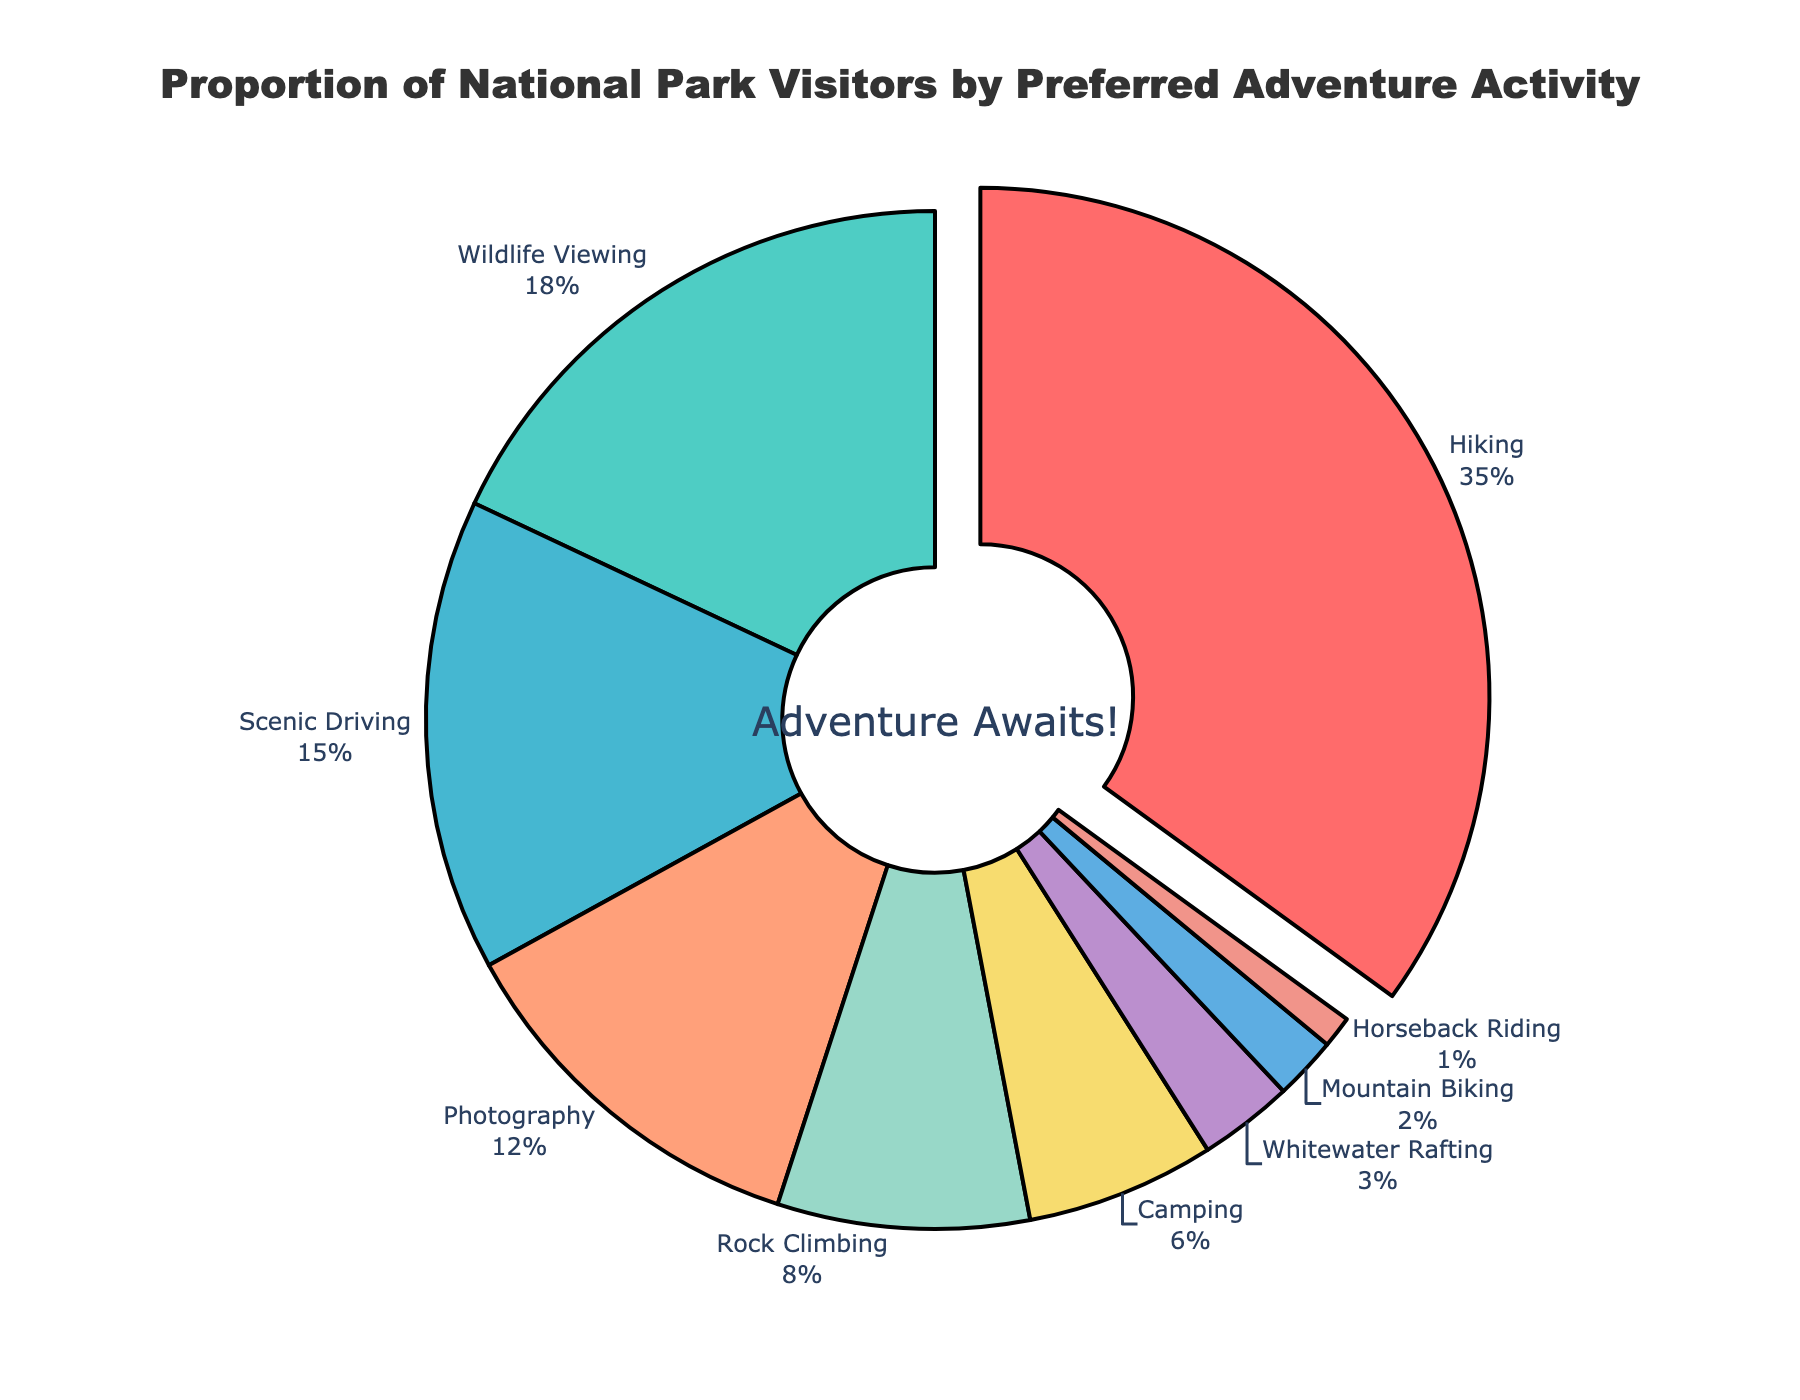Which adventure activity has the highest proportion of visitors? The pie chart highlights that "Hiking" has the largest segment, and it is also the only activity pulled out to emphasize its highest percentage.
Answer: Hiking What is the combined percentage of visitors who prefer Wildlife Viewing and Scenic Driving? From the chart, Wildlife Viewing has 18% and Scenic Driving has 15%. Summing these percentages: 18% + 15% = 33%.
Answer: 33% How much more popular is Hiking compared to Photography among national park visitors? Hiking is at 35% while Photography is at 12%. The difference is 35% - 12% = 23%.
Answer: 23% Which activity has a smaller proportion: Mountain Biking or Horseback Riding? Checking the pie chart, Mountain Biking is at 2%, and Horseback Riding is at 1%. Hence, Horseback Riding has a smaller proportion.
Answer: Horseback Riding What is the visual attribute used to emphasize the most popular activity? In the pie chart, the segment for Hiking is slightly pulled out from the circle to highlight it as the most popular activity.
Answer: Segment is pulled out What is the total percentage of visitors engaged in activities that involve some form of physical exertion (Hiking, Rock Climbing, Camping, Mountain Biking, Horseback Riding)? Adding the percentages: Hiking (35%) + Rock Climbing (8%) + Camping (6%) + Mountain Biking (2%) + Horseback Riding (1%) = 52%.
Answer: 52% What activity has a proportion closest to that of Camping? Camping has a percentage of 6%, and on comparison with others, Rock Climbing has a percentage of 8%, which is closest.
Answer: Rock Climbing Which color is associated with the Wildlife Viewing segment in the pie chart? Observing the pie chart, the color used for the Wildlife Viewing segment is turquoise.
Answer: Turquoise What percentage of visitors prefer activities that involve being on the water (Whitewater Rafting)? Directly from the pie chart, the percentage of visitors who prefer Whitewater Rafting is shown as 3%.
Answer: 3% 